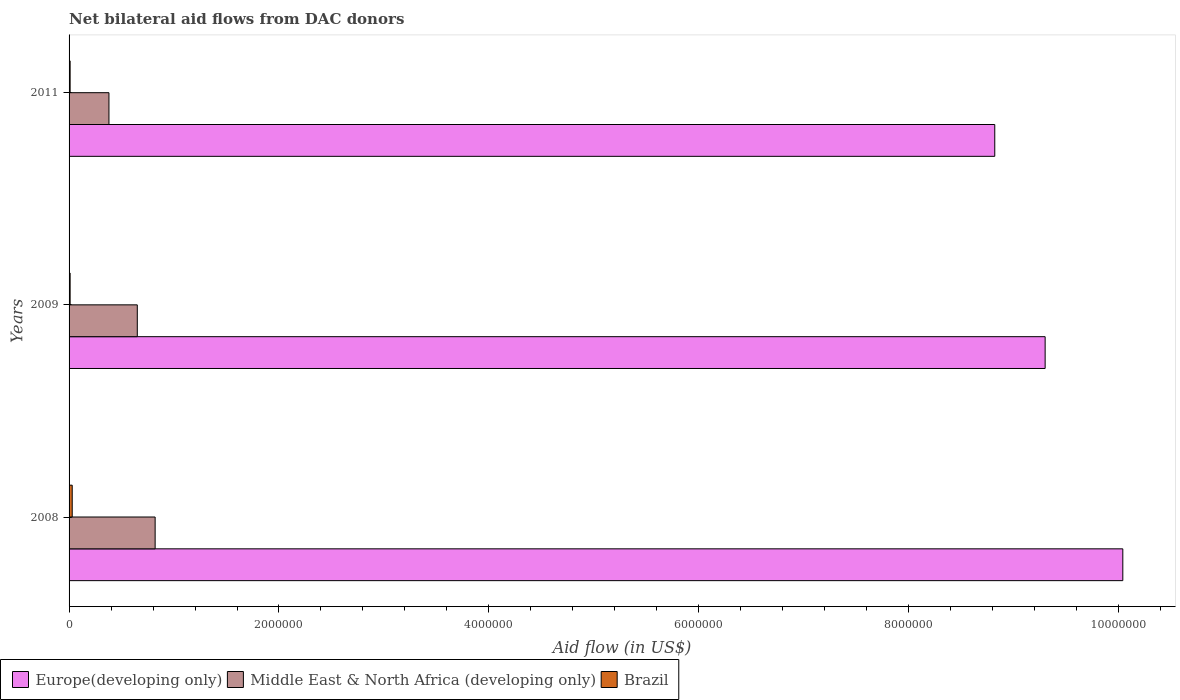How many groups of bars are there?
Make the answer very short. 3. Are the number of bars on each tick of the Y-axis equal?
Provide a short and direct response. Yes. What is the net bilateral aid flow in Middle East & North Africa (developing only) in 2009?
Give a very brief answer. 6.50e+05. Across all years, what is the maximum net bilateral aid flow in Europe(developing only)?
Ensure brevity in your answer.  1.00e+07. Across all years, what is the minimum net bilateral aid flow in Europe(developing only)?
Your answer should be compact. 8.82e+06. In which year was the net bilateral aid flow in Brazil maximum?
Give a very brief answer. 2008. In which year was the net bilateral aid flow in Brazil minimum?
Make the answer very short. 2009. What is the total net bilateral aid flow in Europe(developing only) in the graph?
Give a very brief answer. 2.82e+07. What is the difference between the net bilateral aid flow in Brazil in 2008 and that in 2011?
Offer a terse response. 2.00e+04. What is the difference between the net bilateral aid flow in Europe(developing only) in 2011 and the net bilateral aid flow in Middle East & North Africa (developing only) in 2008?
Offer a very short reply. 8.00e+06. What is the average net bilateral aid flow in Brazil per year?
Your answer should be compact. 1.67e+04. In the year 2011, what is the difference between the net bilateral aid flow in Brazil and net bilateral aid flow in Middle East & North Africa (developing only)?
Ensure brevity in your answer.  -3.70e+05. What is the ratio of the net bilateral aid flow in Middle East & North Africa (developing only) in 2009 to that in 2011?
Offer a very short reply. 1.71. Is the difference between the net bilateral aid flow in Brazil in 2008 and 2009 greater than the difference between the net bilateral aid flow in Middle East & North Africa (developing only) in 2008 and 2009?
Your answer should be compact. No. What is the difference between the highest and the second highest net bilateral aid flow in Europe(developing only)?
Offer a very short reply. 7.40e+05. What is the difference between the highest and the lowest net bilateral aid flow in Europe(developing only)?
Make the answer very short. 1.22e+06. In how many years, is the net bilateral aid flow in Europe(developing only) greater than the average net bilateral aid flow in Europe(developing only) taken over all years?
Ensure brevity in your answer.  1. What does the 3rd bar from the top in 2008 represents?
Keep it short and to the point. Europe(developing only). What does the 2nd bar from the bottom in 2011 represents?
Your answer should be very brief. Middle East & North Africa (developing only). Is it the case that in every year, the sum of the net bilateral aid flow in Middle East & North Africa (developing only) and net bilateral aid flow in Europe(developing only) is greater than the net bilateral aid flow in Brazil?
Give a very brief answer. Yes. How many bars are there?
Ensure brevity in your answer.  9. Are all the bars in the graph horizontal?
Give a very brief answer. Yes. What is the difference between two consecutive major ticks on the X-axis?
Keep it short and to the point. 2.00e+06. Are the values on the major ticks of X-axis written in scientific E-notation?
Ensure brevity in your answer.  No. Where does the legend appear in the graph?
Offer a terse response. Bottom left. How many legend labels are there?
Provide a short and direct response. 3. How are the legend labels stacked?
Provide a succinct answer. Horizontal. What is the title of the graph?
Keep it short and to the point. Net bilateral aid flows from DAC donors. Does "Comoros" appear as one of the legend labels in the graph?
Make the answer very short. No. What is the label or title of the X-axis?
Your answer should be very brief. Aid flow (in US$). What is the Aid flow (in US$) in Europe(developing only) in 2008?
Provide a succinct answer. 1.00e+07. What is the Aid flow (in US$) of Middle East & North Africa (developing only) in 2008?
Provide a short and direct response. 8.20e+05. What is the Aid flow (in US$) of Europe(developing only) in 2009?
Provide a succinct answer. 9.30e+06. What is the Aid flow (in US$) of Middle East & North Africa (developing only) in 2009?
Ensure brevity in your answer.  6.50e+05. What is the Aid flow (in US$) of Brazil in 2009?
Provide a succinct answer. 10000. What is the Aid flow (in US$) in Europe(developing only) in 2011?
Ensure brevity in your answer.  8.82e+06. What is the Aid flow (in US$) in Middle East & North Africa (developing only) in 2011?
Make the answer very short. 3.80e+05. Across all years, what is the maximum Aid flow (in US$) in Europe(developing only)?
Your answer should be very brief. 1.00e+07. Across all years, what is the maximum Aid flow (in US$) of Middle East & North Africa (developing only)?
Provide a short and direct response. 8.20e+05. Across all years, what is the maximum Aid flow (in US$) of Brazil?
Provide a succinct answer. 3.00e+04. Across all years, what is the minimum Aid flow (in US$) in Europe(developing only)?
Provide a succinct answer. 8.82e+06. Across all years, what is the minimum Aid flow (in US$) of Brazil?
Keep it short and to the point. 10000. What is the total Aid flow (in US$) in Europe(developing only) in the graph?
Your response must be concise. 2.82e+07. What is the total Aid flow (in US$) in Middle East & North Africa (developing only) in the graph?
Offer a very short reply. 1.85e+06. What is the total Aid flow (in US$) in Brazil in the graph?
Your answer should be compact. 5.00e+04. What is the difference between the Aid flow (in US$) in Europe(developing only) in 2008 and that in 2009?
Provide a short and direct response. 7.40e+05. What is the difference between the Aid flow (in US$) in Brazil in 2008 and that in 2009?
Make the answer very short. 2.00e+04. What is the difference between the Aid flow (in US$) of Europe(developing only) in 2008 and that in 2011?
Ensure brevity in your answer.  1.22e+06. What is the difference between the Aid flow (in US$) in Middle East & North Africa (developing only) in 2008 and that in 2011?
Make the answer very short. 4.40e+05. What is the difference between the Aid flow (in US$) in Brazil in 2008 and that in 2011?
Offer a terse response. 2.00e+04. What is the difference between the Aid flow (in US$) of Europe(developing only) in 2009 and that in 2011?
Make the answer very short. 4.80e+05. What is the difference between the Aid flow (in US$) of Middle East & North Africa (developing only) in 2009 and that in 2011?
Offer a terse response. 2.70e+05. What is the difference between the Aid flow (in US$) in Brazil in 2009 and that in 2011?
Your response must be concise. 0. What is the difference between the Aid flow (in US$) in Europe(developing only) in 2008 and the Aid flow (in US$) in Middle East & North Africa (developing only) in 2009?
Ensure brevity in your answer.  9.39e+06. What is the difference between the Aid flow (in US$) of Europe(developing only) in 2008 and the Aid flow (in US$) of Brazil in 2009?
Offer a very short reply. 1.00e+07. What is the difference between the Aid flow (in US$) of Middle East & North Africa (developing only) in 2008 and the Aid flow (in US$) of Brazil in 2009?
Your answer should be very brief. 8.10e+05. What is the difference between the Aid flow (in US$) of Europe(developing only) in 2008 and the Aid flow (in US$) of Middle East & North Africa (developing only) in 2011?
Keep it short and to the point. 9.66e+06. What is the difference between the Aid flow (in US$) of Europe(developing only) in 2008 and the Aid flow (in US$) of Brazil in 2011?
Provide a short and direct response. 1.00e+07. What is the difference between the Aid flow (in US$) of Middle East & North Africa (developing only) in 2008 and the Aid flow (in US$) of Brazil in 2011?
Offer a terse response. 8.10e+05. What is the difference between the Aid flow (in US$) of Europe(developing only) in 2009 and the Aid flow (in US$) of Middle East & North Africa (developing only) in 2011?
Make the answer very short. 8.92e+06. What is the difference between the Aid flow (in US$) in Europe(developing only) in 2009 and the Aid flow (in US$) in Brazil in 2011?
Ensure brevity in your answer.  9.29e+06. What is the difference between the Aid flow (in US$) in Middle East & North Africa (developing only) in 2009 and the Aid flow (in US$) in Brazil in 2011?
Keep it short and to the point. 6.40e+05. What is the average Aid flow (in US$) in Europe(developing only) per year?
Give a very brief answer. 9.39e+06. What is the average Aid flow (in US$) in Middle East & North Africa (developing only) per year?
Your response must be concise. 6.17e+05. What is the average Aid flow (in US$) of Brazil per year?
Ensure brevity in your answer.  1.67e+04. In the year 2008, what is the difference between the Aid flow (in US$) in Europe(developing only) and Aid flow (in US$) in Middle East & North Africa (developing only)?
Your answer should be compact. 9.22e+06. In the year 2008, what is the difference between the Aid flow (in US$) in Europe(developing only) and Aid flow (in US$) in Brazil?
Keep it short and to the point. 1.00e+07. In the year 2008, what is the difference between the Aid flow (in US$) in Middle East & North Africa (developing only) and Aid flow (in US$) in Brazil?
Ensure brevity in your answer.  7.90e+05. In the year 2009, what is the difference between the Aid flow (in US$) of Europe(developing only) and Aid flow (in US$) of Middle East & North Africa (developing only)?
Keep it short and to the point. 8.65e+06. In the year 2009, what is the difference between the Aid flow (in US$) of Europe(developing only) and Aid flow (in US$) of Brazil?
Your answer should be compact. 9.29e+06. In the year 2009, what is the difference between the Aid flow (in US$) of Middle East & North Africa (developing only) and Aid flow (in US$) of Brazil?
Provide a succinct answer. 6.40e+05. In the year 2011, what is the difference between the Aid flow (in US$) of Europe(developing only) and Aid flow (in US$) of Middle East & North Africa (developing only)?
Your answer should be very brief. 8.44e+06. In the year 2011, what is the difference between the Aid flow (in US$) of Europe(developing only) and Aid flow (in US$) of Brazil?
Offer a very short reply. 8.81e+06. What is the ratio of the Aid flow (in US$) in Europe(developing only) in 2008 to that in 2009?
Give a very brief answer. 1.08. What is the ratio of the Aid flow (in US$) in Middle East & North Africa (developing only) in 2008 to that in 2009?
Make the answer very short. 1.26. What is the ratio of the Aid flow (in US$) in Europe(developing only) in 2008 to that in 2011?
Give a very brief answer. 1.14. What is the ratio of the Aid flow (in US$) of Middle East & North Africa (developing only) in 2008 to that in 2011?
Keep it short and to the point. 2.16. What is the ratio of the Aid flow (in US$) of Europe(developing only) in 2009 to that in 2011?
Your answer should be very brief. 1.05. What is the ratio of the Aid flow (in US$) of Middle East & North Africa (developing only) in 2009 to that in 2011?
Your answer should be very brief. 1.71. What is the ratio of the Aid flow (in US$) in Brazil in 2009 to that in 2011?
Provide a succinct answer. 1. What is the difference between the highest and the second highest Aid flow (in US$) of Europe(developing only)?
Your response must be concise. 7.40e+05. What is the difference between the highest and the second highest Aid flow (in US$) in Brazil?
Offer a terse response. 2.00e+04. What is the difference between the highest and the lowest Aid flow (in US$) in Europe(developing only)?
Your response must be concise. 1.22e+06. What is the difference between the highest and the lowest Aid flow (in US$) of Brazil?
Your answer should be compact. 2.00e+04. 